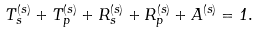<formula> <loc_0><loc_0><loc_500><loc_500>T _ { s } ^ { ( s ) } + T _ { p } ^ { ( s ) } + R _ { s } ^ { ( s ) } + R _ { p } ^ { ( s ) } + A ^ { ( s ) } = 1 .</formula> 